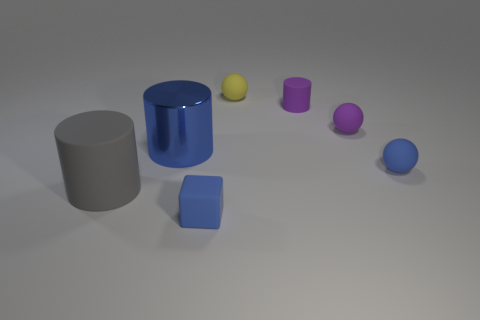Is the blue glossy cylinder taller or shorter than the grey matte cylinder? The blue glossy cylinder is shorter than the grey matte cylinder in the image. 